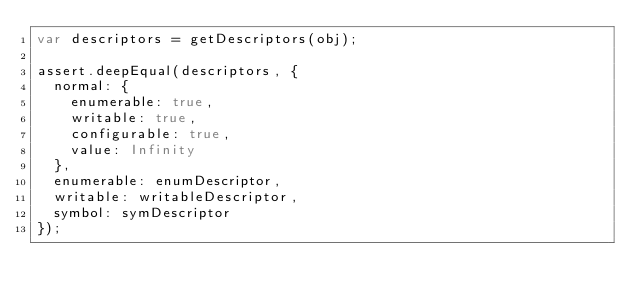<code> <loc_0><loc_0><loc_500><loc_500><_JavaScript_>var descriptors = getDescriptors(obj);

assert.deepEqual(descriptors, {
	normal: {
		enumerable: true,
		writable: true,
		configurable: true,
		value: Infinity
	},
	enumerable: enumDescriptor,
	writable: writableDescriptor,
	symbol: symDescriptor
});
</code> 